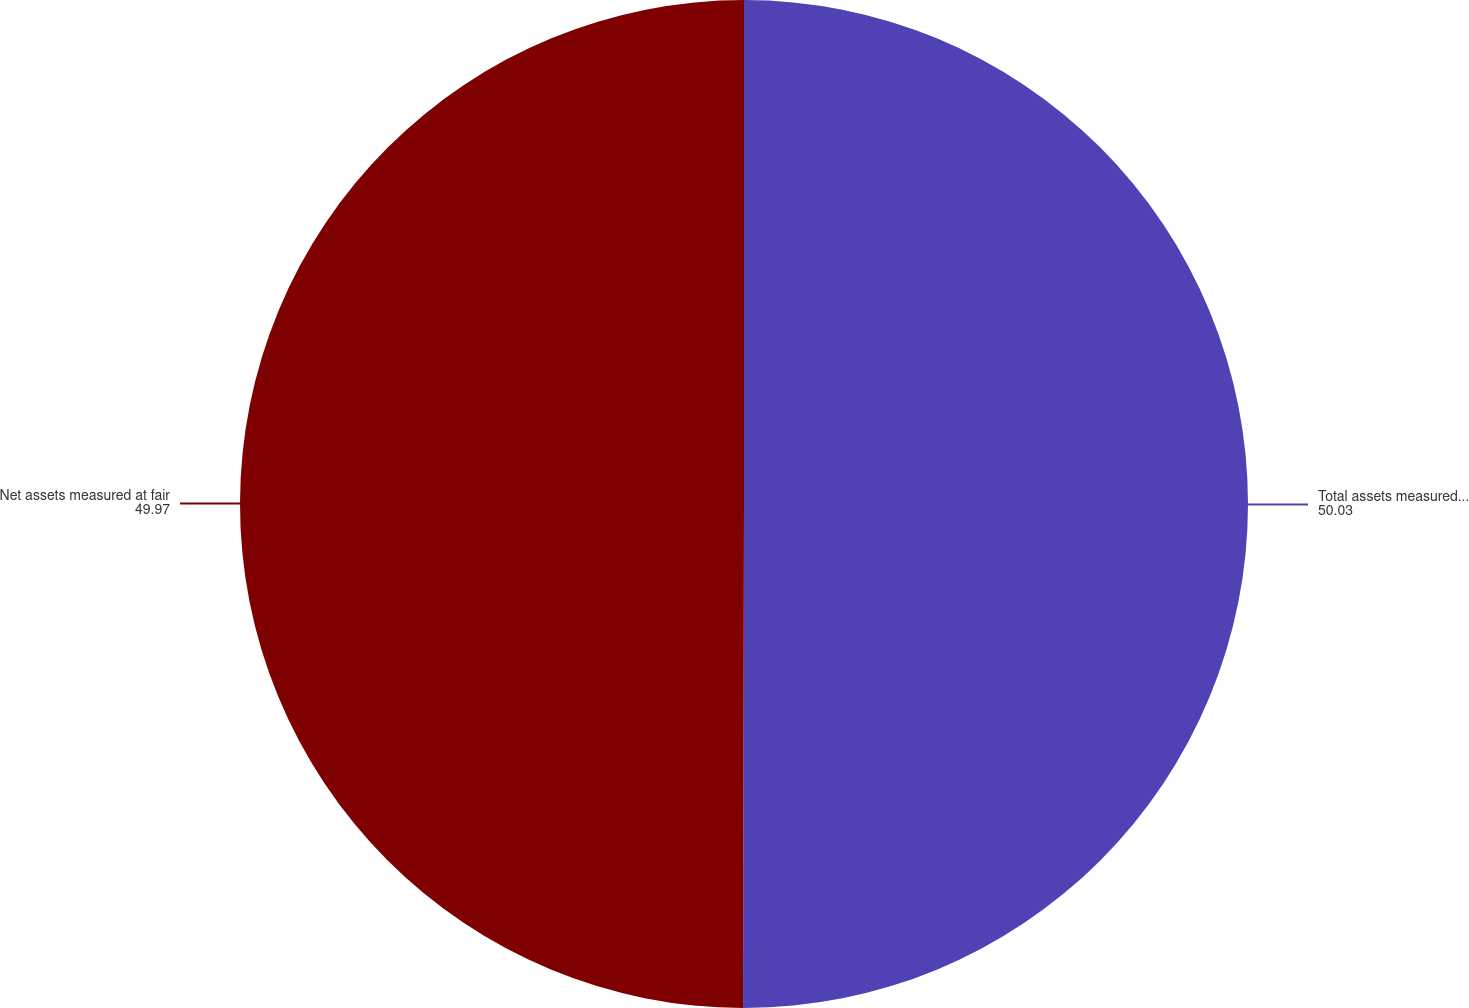<chart> <loc_0><loc_0><loc_500><loc_500><pie_chart><fcel>Total assets measured at fair<fcel>Net assets measured at fair<nl><fcel>50.03%<fcel>49.97%<nl></chart> 